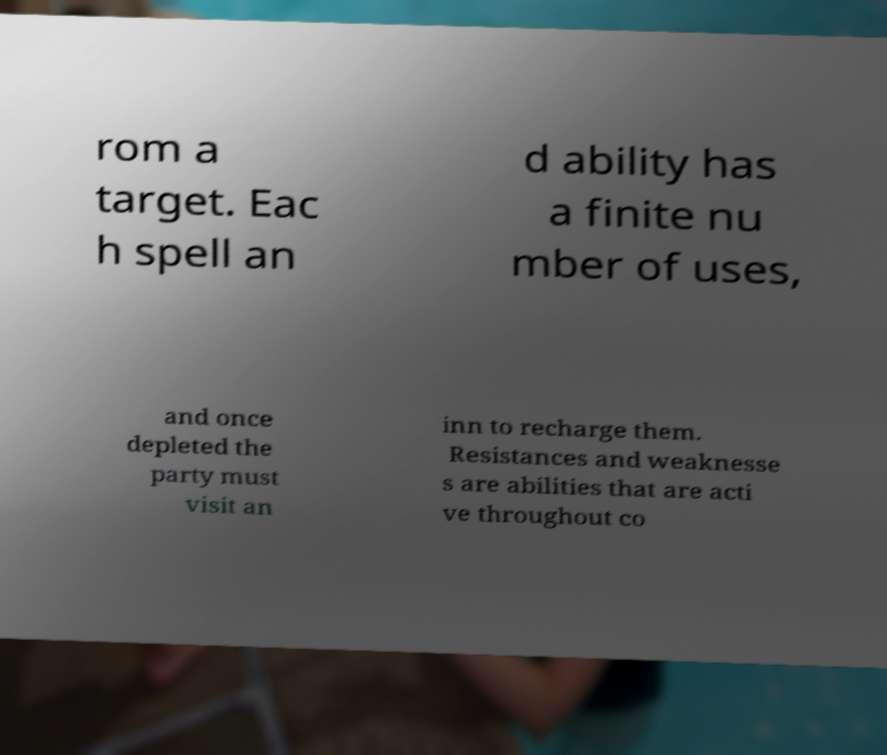There's text embedded in this image that I need extracted. Can you transcribe it verbatim? rom a target. Eac h spell an d ability has a finite nu mber of uses, and once depleted the party must visit an inn to recharge them. Resistances and weaknesse s are abilities that are acti ve throughout co 